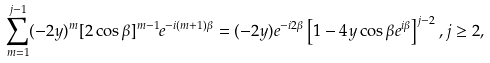<formula> <loc_0><loc_0><loc_500><loc_500>\sum _ { m = 1 } ^ { j - 1 } ( - 2 y ) ^ { m } [ 2 \cos \beta ] ^ { m - 1 } e ^ { - i ( m + 1 ) \beta } = ( - 2 y ) e ^ { - i 2 \beta } \left [ 1 - 4 y \cos \beta e ^ { i \beta } \right ] ^ { j - 2 } , j \geq 2 ,</formula> 